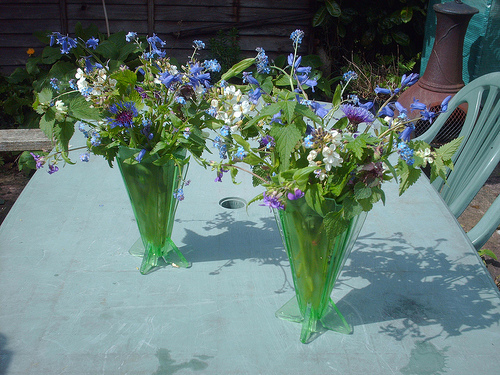Describe the ambiance and setting shown in this image. This serene garden scene exudes a tranquil ambiance with its casual outdoor furniture and vibrant vases of fresh flowers on a weathered blue table, suggesting a private backyard where one might enjoy a peaceful moment amidst nature. What kind of occasion might be appropriate for this setting? The setting is ideal for a relaxing afternoon tea, a casual garden party, or simply a quiet reprieve where someone could indulge in reading a book or savoring the surrounding flora. 